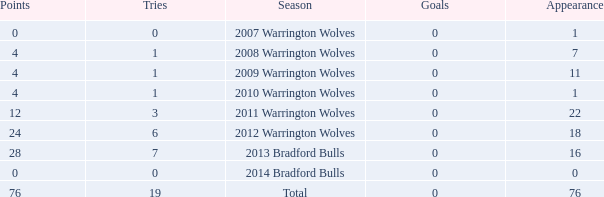What is the average tries for the season 2008 warrington wolves with an appearance more than 7? None. 